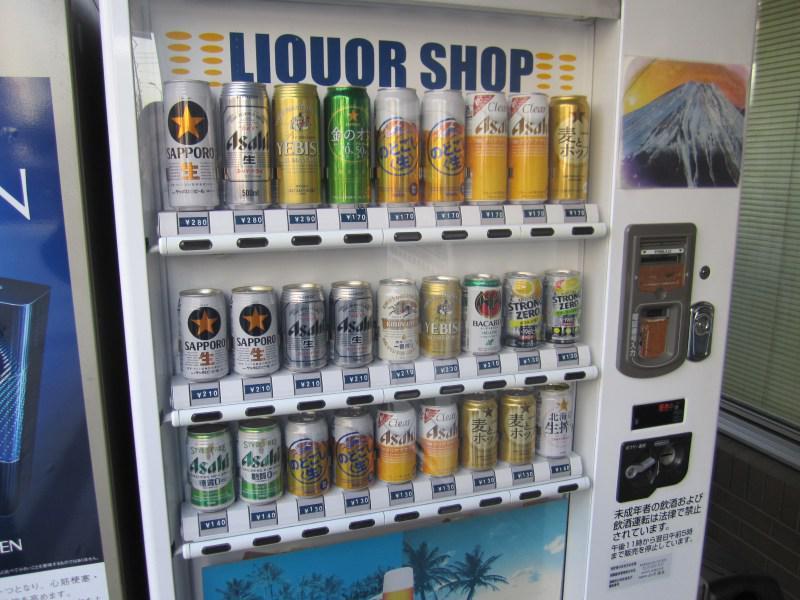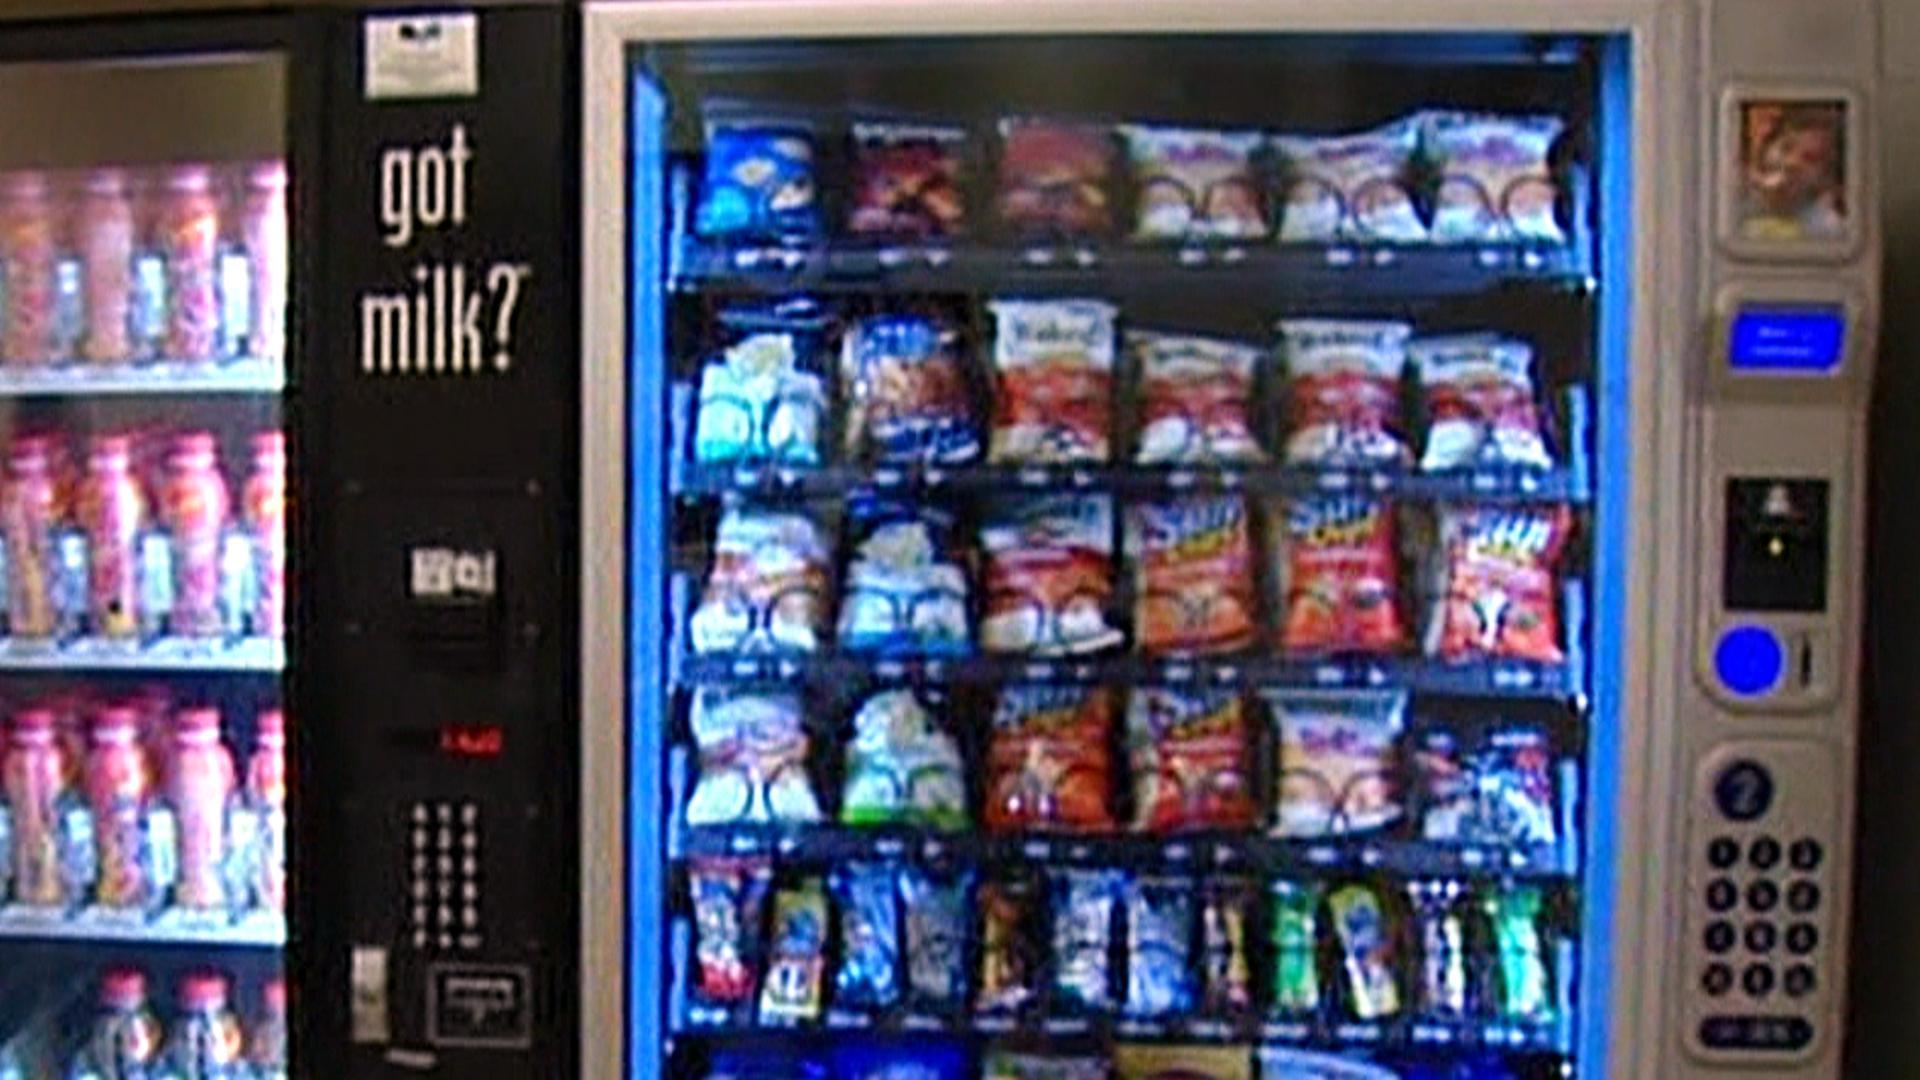The first image is the image on the left, the second image is the image on the right. Examine the images to the left and right. Is the description "There is at least one vending machine with the Pepsi logo on it." accurate? Answer yes or no. No. 